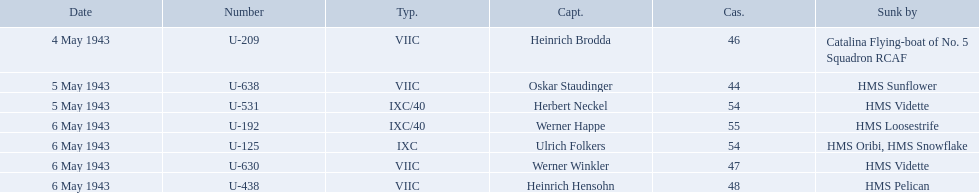What boats were lost on may 5? U-638, U-531. Who were the captains of those boats? Oskar Staudinger, Herbert Neckel. Which captain was not oskar staudinger? Herbert Neckel. Who are the captains of the u boats? Heinrich Brodda, Oskar Staudinger, Herbert Neckel, Werner Happe, Ulrich Folkers, Werner Winkler, Heinrich Hensohn. What are the dates the u boat captains were lost? 4 May 1943, 5 May 1943, 5 May 1943, 6 May 1943, 6 May 1943, 6 May 1943, 6 May 1943. Of these, which were lost on may 5? Oskar Staudinger, Herbert Neckel. Other than oskar staudinger, who else was lost on this day? Herbert Neckel. Which were the names of the sinkers of the convoys? Catalina Flying-boat of No. 5 Squadron RCAF, HMS Sunflower, HMS Vidette, HMS Loosestrife, HMS Oribi, HMS Snowflake, HMS Vidette, HMS Pelican. What captain was sunk by the hms pelican? Heinrich Hensohn. 